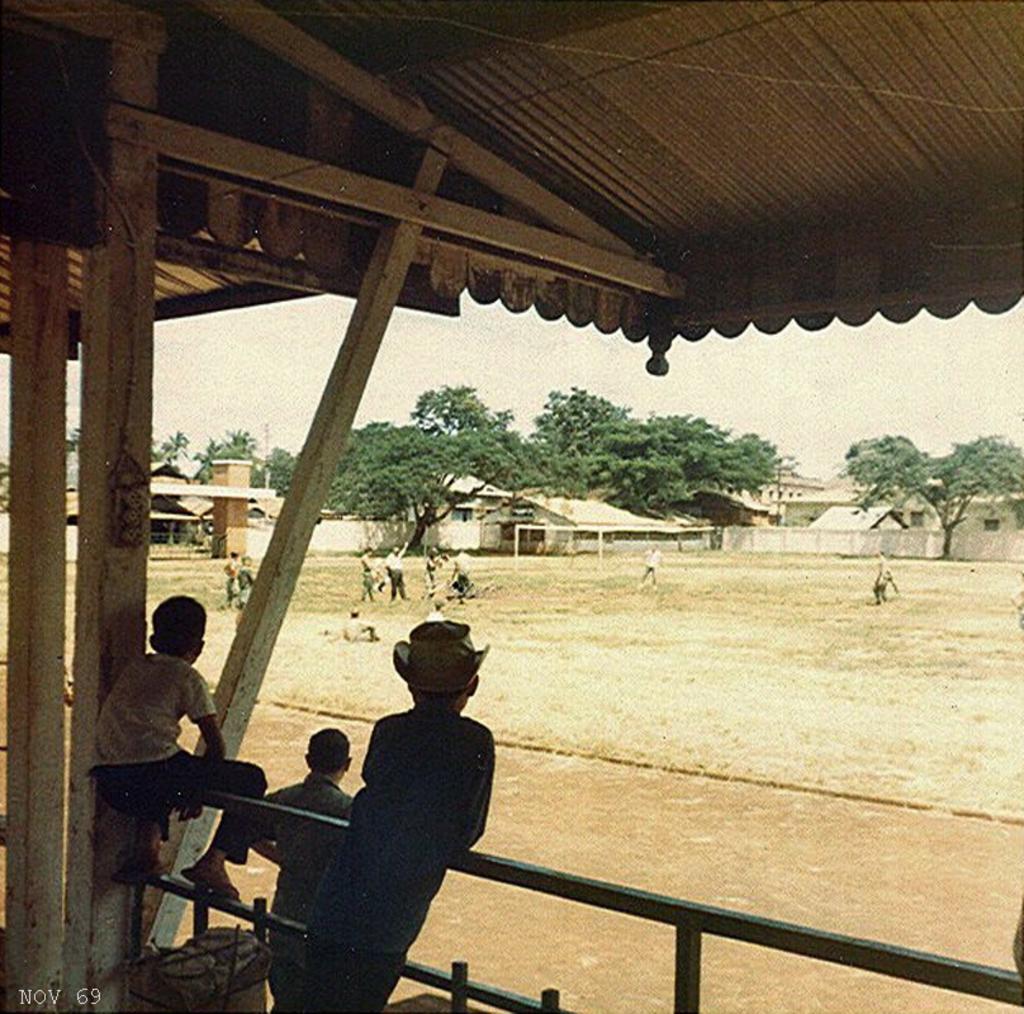Can you describe this image briefly? In this image we can see persons standing on the railing, persons standing on the ground, trees, shed , walls and sky. 